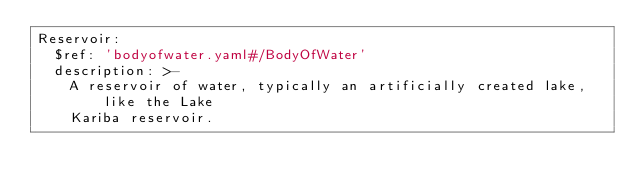<code> <loc_0><loc_0><loc_500><loc_500><_YAML_>Reservoir:
  $ref: 'bodyofwater.yaml#/BodyOfWater'
  description: >-
    A reservoir of water, typically an artificially created lake, like the Lake
    Kariba reservoir.
</code> 